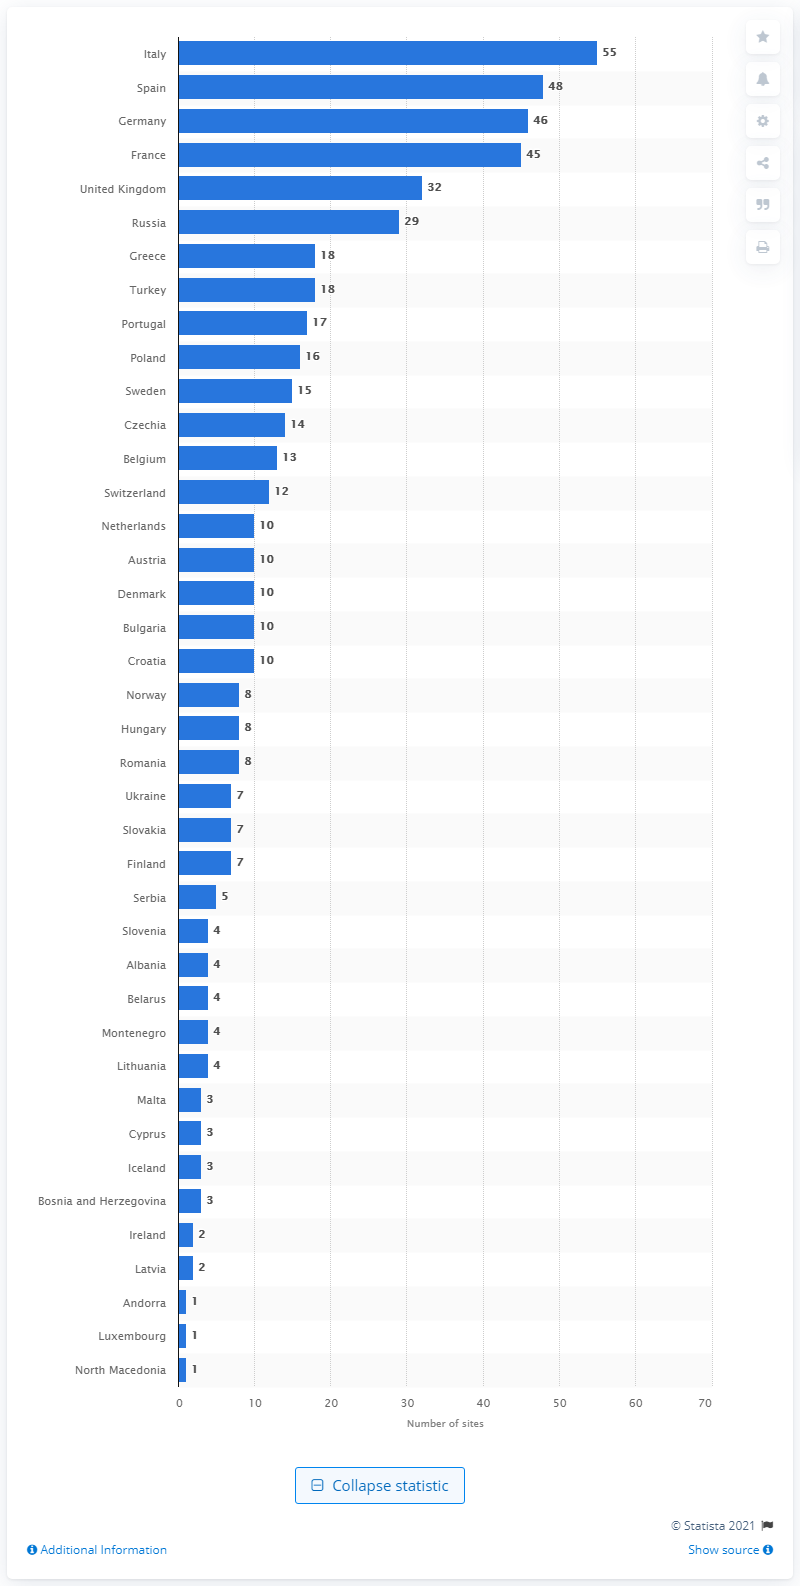Indicate a few pertinent items in this graphic. There are 55 sites in Italy. 